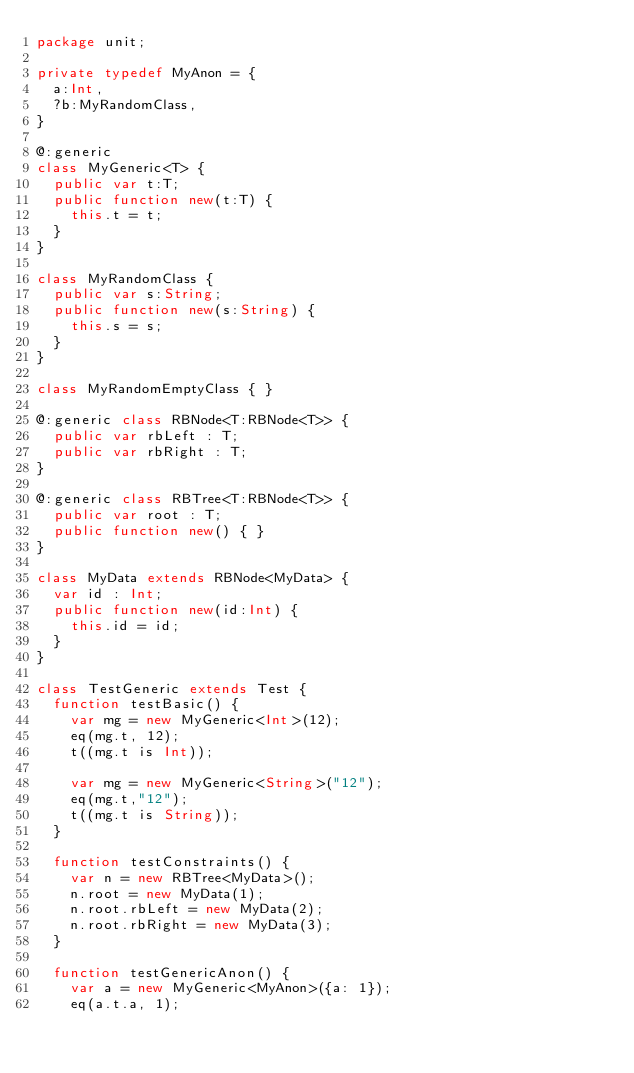Convert code to text. <code><loc_0><loc_0><loc_500><loc_500><_Haxe_>package unit;

private typedef MyAnon = {
	a:Int,
	?b:MyRandomClass,
}

@:generic
class MyGeneric<T> {
	public var t:T;
	public function new(t:T) {
		this.t = t;
	}
}

class MyRandomClass {
	public var s:String;
	public function new(s:String) {
		this.s = s;
	}
}

class MyRandomEmptyClass { }

@:generic class RBNode<T:RBNode<T>> {
	public var rbLeft : T;
	public var rbRight : T;
}

@:generic class RBTree<T:RBNode<T>> {
	public var root : T;
	public function new() {	}
}

class MyData extends RBNode<MyData> {
	var id : Int;
	public function new(id:Int) {
		this.id = id;
	}
}

class TestGeneric extends Test {
	function testBasic() {
		var mg = new MyGeneric<Int>(12);
		eq(mg.t, 12);
		t((mg.t is Int));

		var mg = new MyGeneric<String>("12");
		eq(mg.t,"12");
		t((mg.t is String));
	}

	function testConstraints() {
		var n = new RBTree<MyData>();
		n.root = new MyData(1);
		n.root.rbLeft = new MyData(2);
		n.root.rbRight = new MyData(3);
	}

	function testGenericAnon() {
		var a = new MyGeneric<MyAnon>({a: 1});
		eq(a.t.a, 1);</code> 